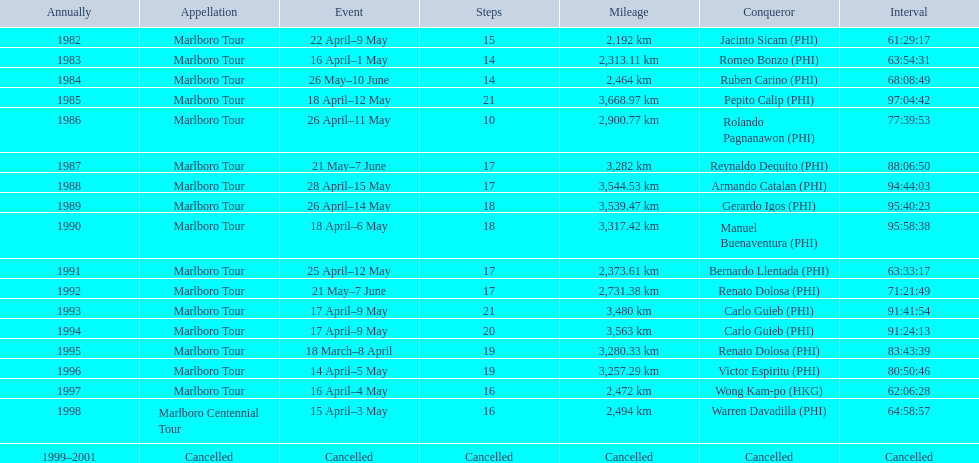How far did the marlboro tour travel each year? 2,192 km, 2,313.11 km, 2,464 km, 3,668.97 km, 2,900.77 km, 3,282 km, 3,544.53 km, 3,539.47 km, 3,317.42 km, 2,373.61 km, 2,731.38 km, 3,480 km, 3,563 km, 3,280.33 km, 3,257.29 km, 2,472 km, 2,494 km, Cancelled. In what year did they travel the furthest? 1985. How far did they travel that year? 3,668.97 km. 